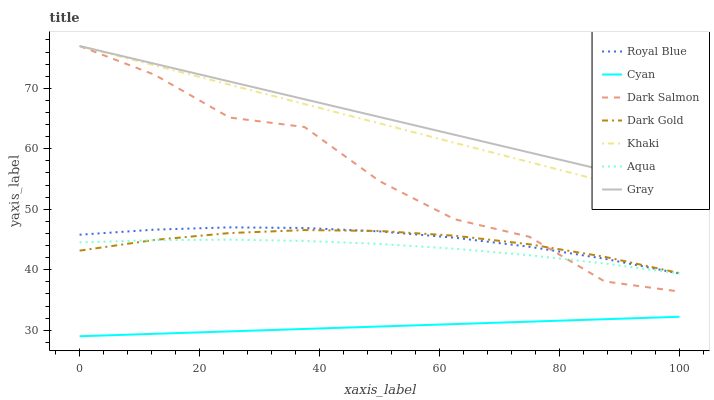Does Cyan have the minimum area under the curve?
Answer yes or no. Yes. Does Gray have the maximum area under the curve?
Answer yes or no. Yes. Does Khaki have the minimum area under the curve?
Answer yes or no. No. Does Khaki have the maximum area under the curve?
Answer yes or no. No. Is Cyan the smoothest?
Answer yes or no. Yes. Is Dark Salmon the roughest?
Answer yes or no. Yes. Is Khaki the smoothest?
Answer yes or no. No. Is Khaki the roughest?
Answer yes or no. No. Does Cyan have the lowest value?
Answer yes or no. Yes. Does Khaki have the lowest value?
Answer yes or no. No. Does Dark Salmon have the highest value?
Answer yes or no. Yes. Does Dark Gold have the highest value?
Answer yes or no. No. Is Cyan less than Khaki?
Answer yes or no. Yes. Is Dark Salmon greater than Cyan?
Answer yes or no. Yes. Does Dark Gold intersect Royal Blue?
Answer yes or no. Yes. Is Dark Gold less than Royal Blue?
Answer yes or no. No. Is Dark Gold greater than Royal Blue?
Answer yes or no. No. Does Cyan intersect Khaki?
Answer yes or no. No. 